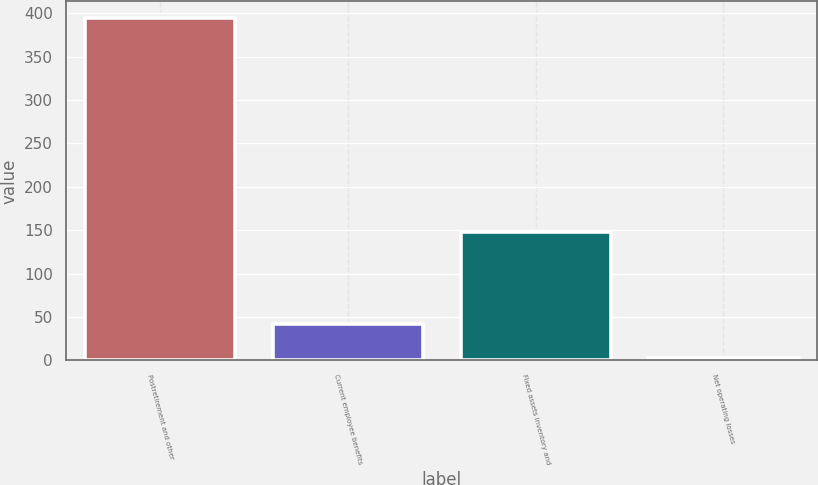Convert chart. <chart><loc_0><loc_0><loc_500><loc_500><bar_chart><fcel>Postretirement and other<fcel>Current employee benefits<fcel>Fixed assets inventory and<fcel>Net operating losses<nl><fcel>394<fcel>42.1<fcel>148<fcel>3<nl></chart> 